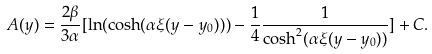Convert formula to latex. <formula><loc_0><loc_0><loc_500><loc_500>A ( y ) = \frac { 2 \beta } { 3 \alpha } [ \ln ( \cosh ( \alpha \xi ( y - y _ { 0 } ) ) ) - \frac { 1 } { 4 } \frac { 1 } { \cosh ^ { 2 } ( \alpha \xi ( y - y _ { 0 } ) ) } ] + C .</formula> 